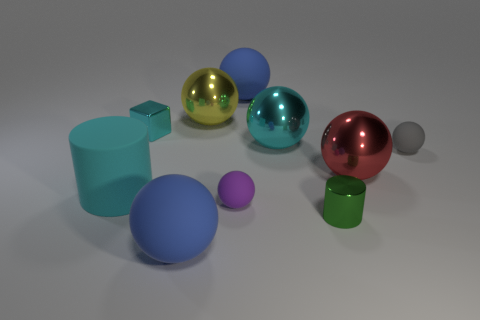Subtract 4 balls. How many balls are left? 3 Subtract all blue spheres. How many spheres are left? 5 Subtract all cyan spheres. How many spheres are left? 6 Subtract all purple balls. Subtract all green cylinders. How many balls are left? 6 Subtract all spheres. How many objects are left? 3 Subtract all matte balls. Subtract all purple balls. How many objects are left? 5 Add 2 balls. How many balls are left? 9 Add 2 large gray metal spheres. How many large gray metal spheres exist? 2 Subtract 0 blue cylinders. How many objects are left? 10 